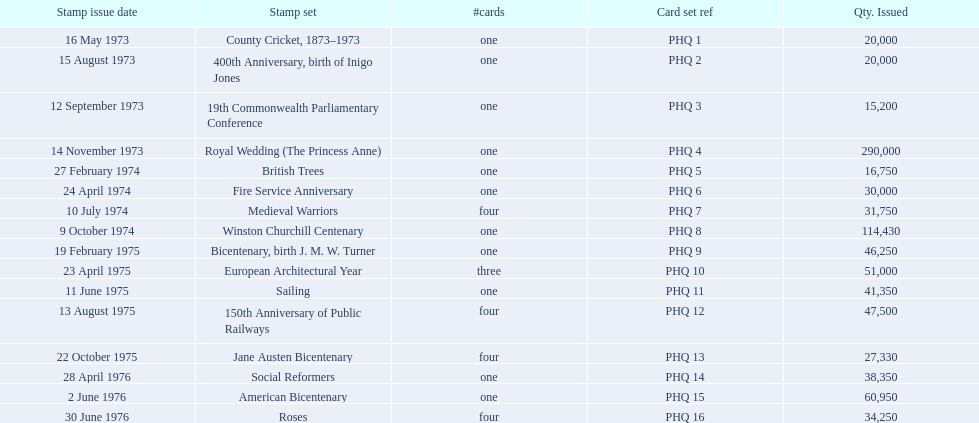Which stamp set had only three cards in the set? European Architectural Year. 